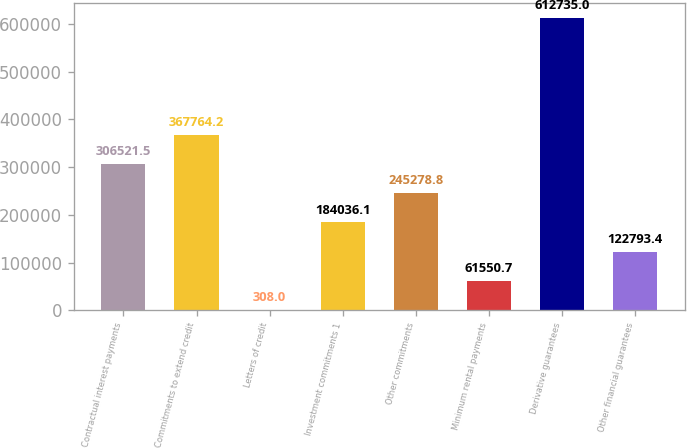<chart> <loc_0><loc_0><loc_500><loc_500><bar_chart><fcel>Contractual interest payments<fcel>Commitments to extend credit<fcel>Letters of credit<fcel>Investment commitments 1<fcel>Other commitments<fcel>Minimum rental payments<fcel>Derivative guarantees<fcel>Other financial guarantees<nl><fcel>306522<fcel>367764<fcel>308<fcel>184036<fcel>245279<fcel>61550.7<fcel>612735<fcel>122793<nl></chart> 